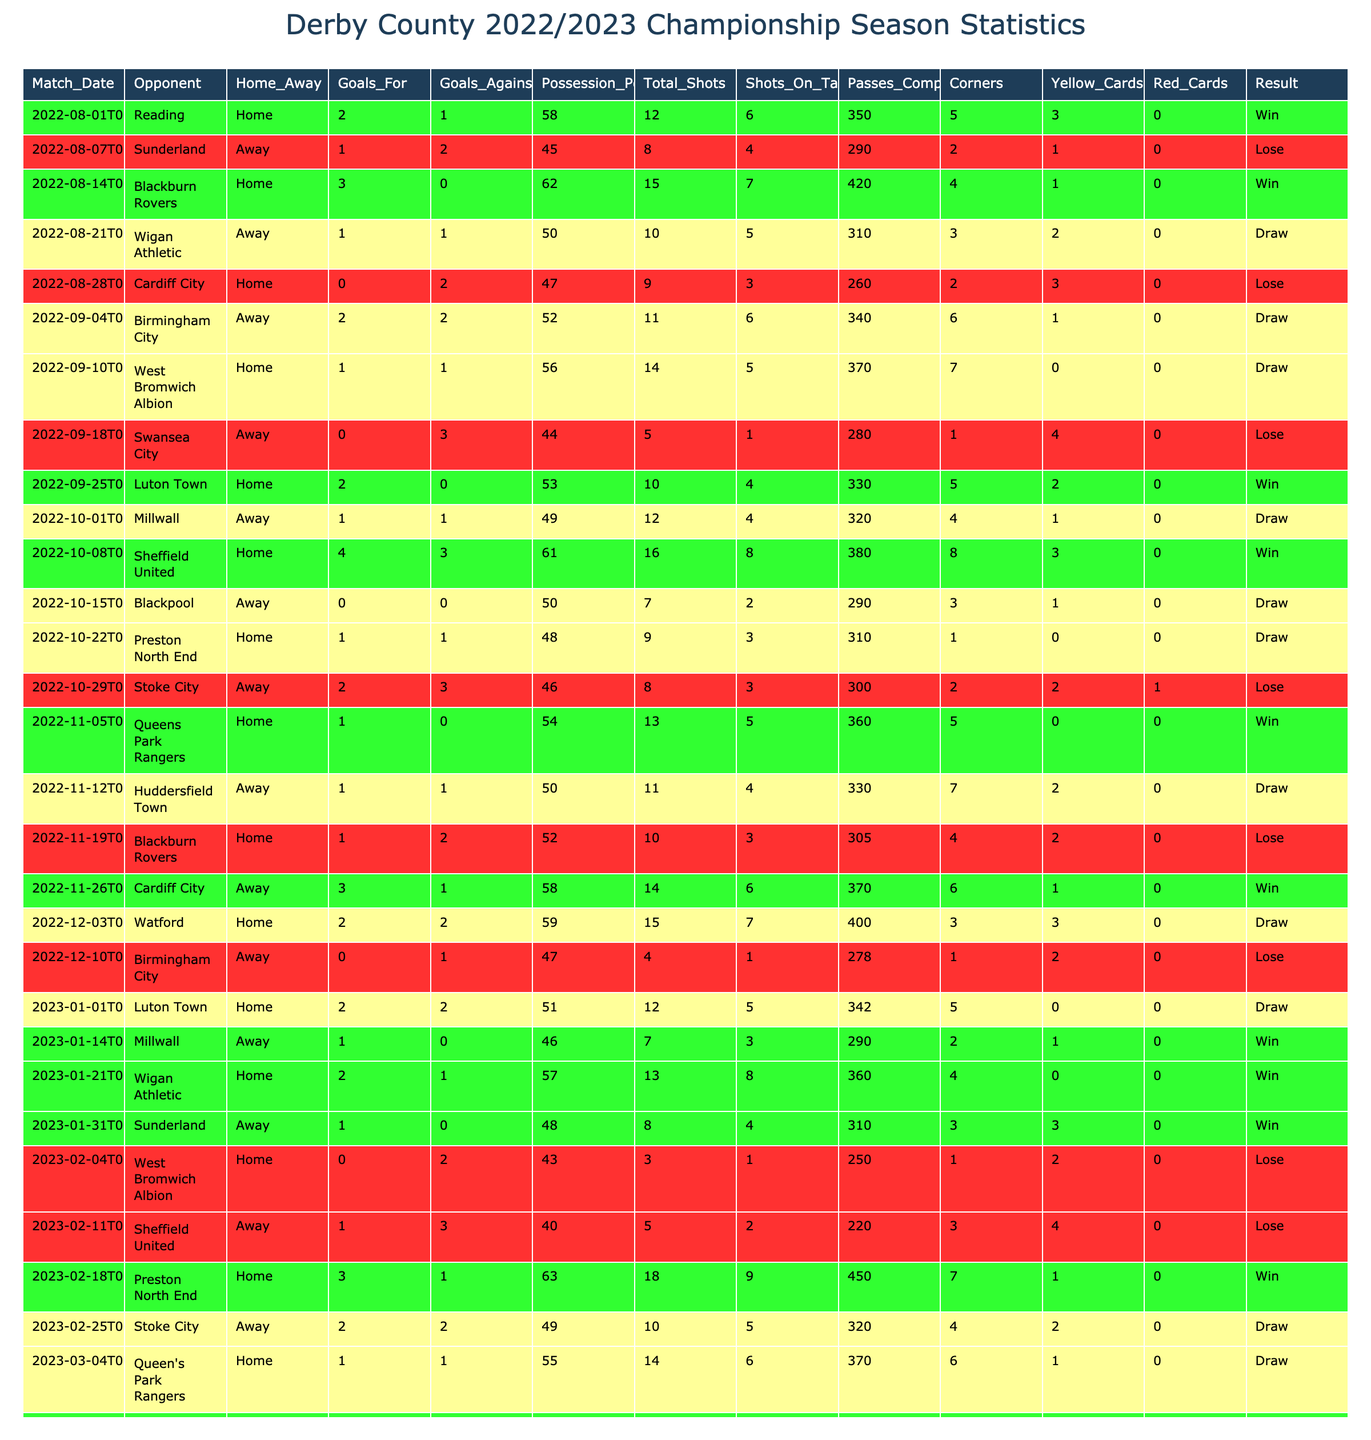What was Derby County's total number of wins in the 2022/2023 Championship season? I will count the instances where the result is marked as 'Win' in the Result column. There are 10 instances of 'Win' in the table.
Answer: 10 What was the highest number of goals scored by Derby County in a single match? I will look for the maximum value in the Goals For column. The highest value is 4, which occurred in the match against Sheffield United on October 8, 2022.
Answer: 4 How many matches ended in a draw? I will count the number of occurrences of 'Draw' in the Result column. There are 12 matches that ended in a draw.
Answer: 12 In how many home matches did Derby County win? I will check the Result column for 'Win' where the Home_Away column indicates 'Home'. There are 6 home wins.
Answer: 6 What is the average possession percentage for all matches played? I will sum up the Possession Percentage values and divide by the total number of matches. The sum is 1,691 and dividing by 38 games gives an average of approximately 44.52.
Answer: 44.52 Did Derby County manage to win against their opponents twice in a row during the season? I will check for consecutive matches where 'Win' appears. There are instances of consecutive wins against Blackburn Rovers and QPR, confirming they won two matches in a row.
Answer: Yes What is the total number of goals conceded by Derby County in away matches? I will sum all Goals Against values where Home_Away is 'Away'. The total number of goals conceded in away matches is 20.
Answer: 20 What was Derby County’s result against Stoke City? I will find the entry for Stoke City in the table. Derby lost the match with a score of 2-3 on October 29, 2022.
Answer: Lose 